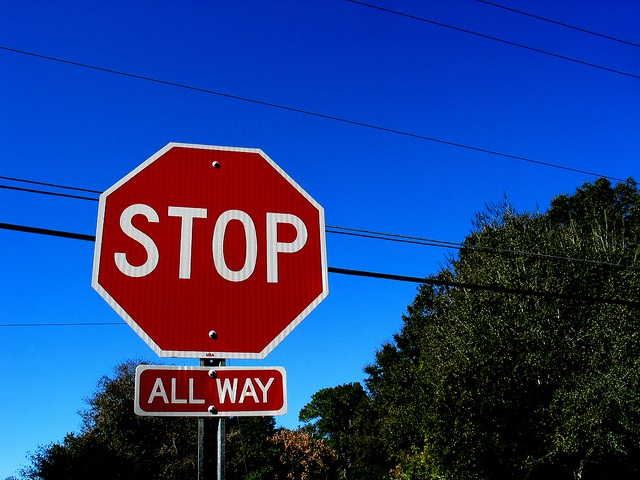Describe the objects in this image and their specific colors. I can see a stop sign in blue, maroon, lightgray, and darkgray tones in this image. 